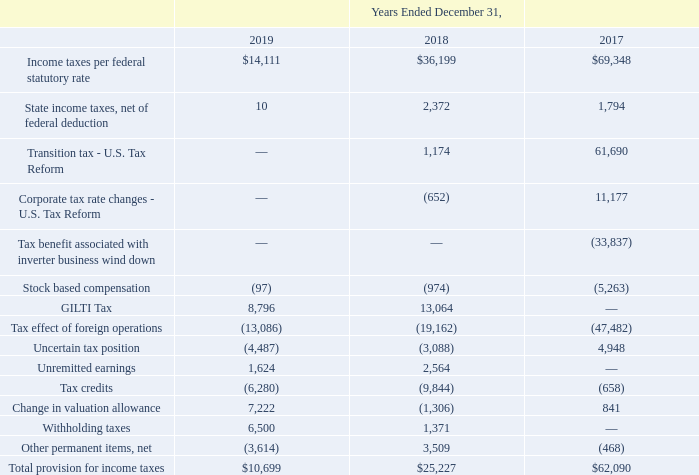ADVANCED ENERGY INDUSTRIES, INC. NOTES TO CONSOLIDATED FINANCIAL STATEMENTS – (continued) (in thousands, except per share amounts)
The Company’s effective tax rate differs from the U.S. federal statutory rate of 35% for the year ended December 31, 2017, primarily due to the benefit related to the wind down of our solar inverter business and earnings in foreign jurisdictions, which are subject to lower tax rates, offset by the impact of U.S. tax reform. The principal causes of the difference between the federal statutory rate and the effective income tax rate for each the years below are as follows:
Why did the company's effective tax rate differ from the U.S. federal statutory rate? Due to the benefit related to the wind down of our solar inverter business and earnings in foreign jurisdictions, which are subject to lower tax rates, offset by the impact of u.s. tax reform. What was the Income taxes per federal statutory rate in 2018?
Answer scale should be: thousand. $36,199. What was the State income taxes, net of federal deduction in 2017?
Answer scale should be: thousand. 1,794. What was the change in GILTI Tax between 2018 and 2019?
Answer scale should be: thousand. 8,796-13,064
Answer: -4268. What was the change in Unremitted earnings between 2018 and 2019?
Answer scale should be: thousand. 1,624-2,564
Answer: -940. What was the percentage change in Withholding taxes between 2018 and 2019?
Answer scale should be: percent. (6,500-1,371)/1,371
Answer: 374.11. 